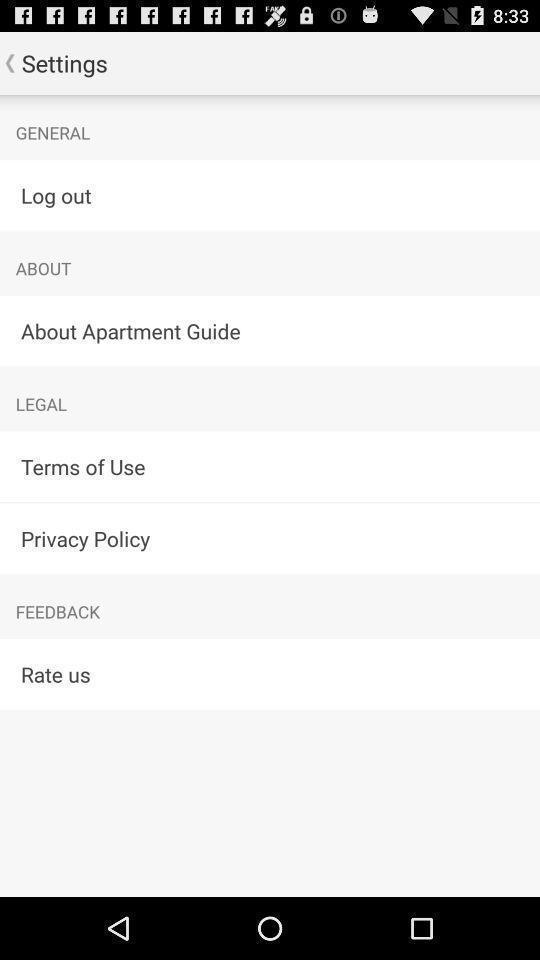Provide a textual representation of this image. Settings page. 